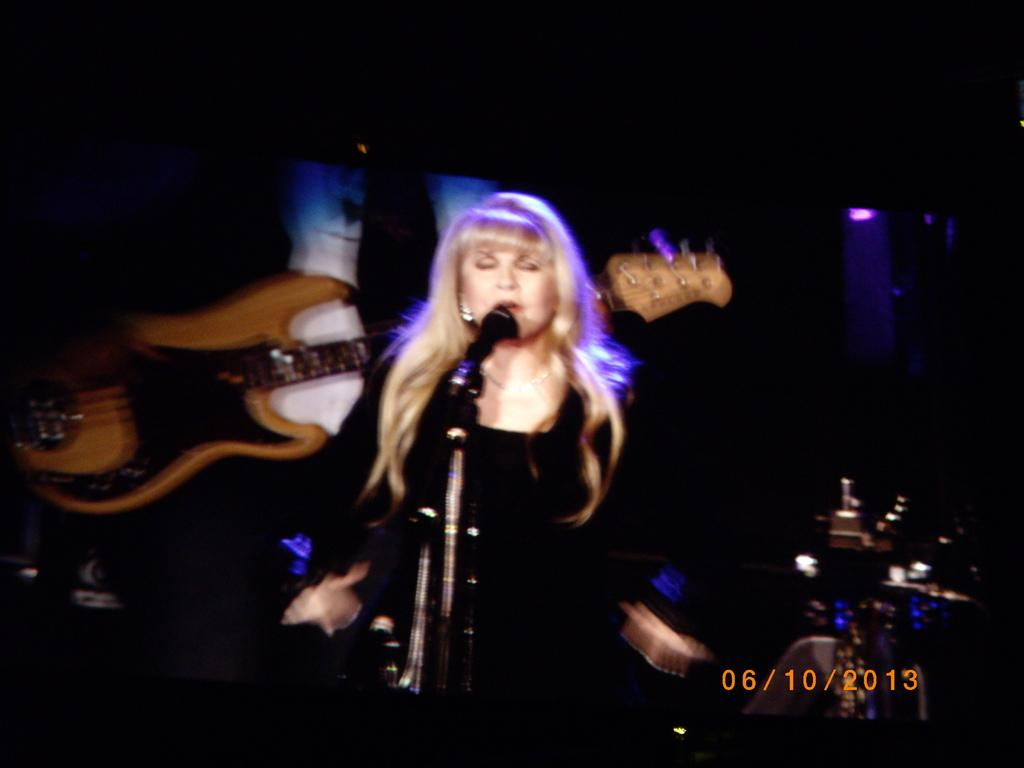Who is the main subject in the image? There is a woman in the image. What is the woman doing in the image? The woman is singing in the image. Can you describe the setting of the image? The setting is a concert. What type of lamp is on stage during the woman's performance? There is no lamp mentioned or visible in the image; it only shows a woman singing at a concert. 